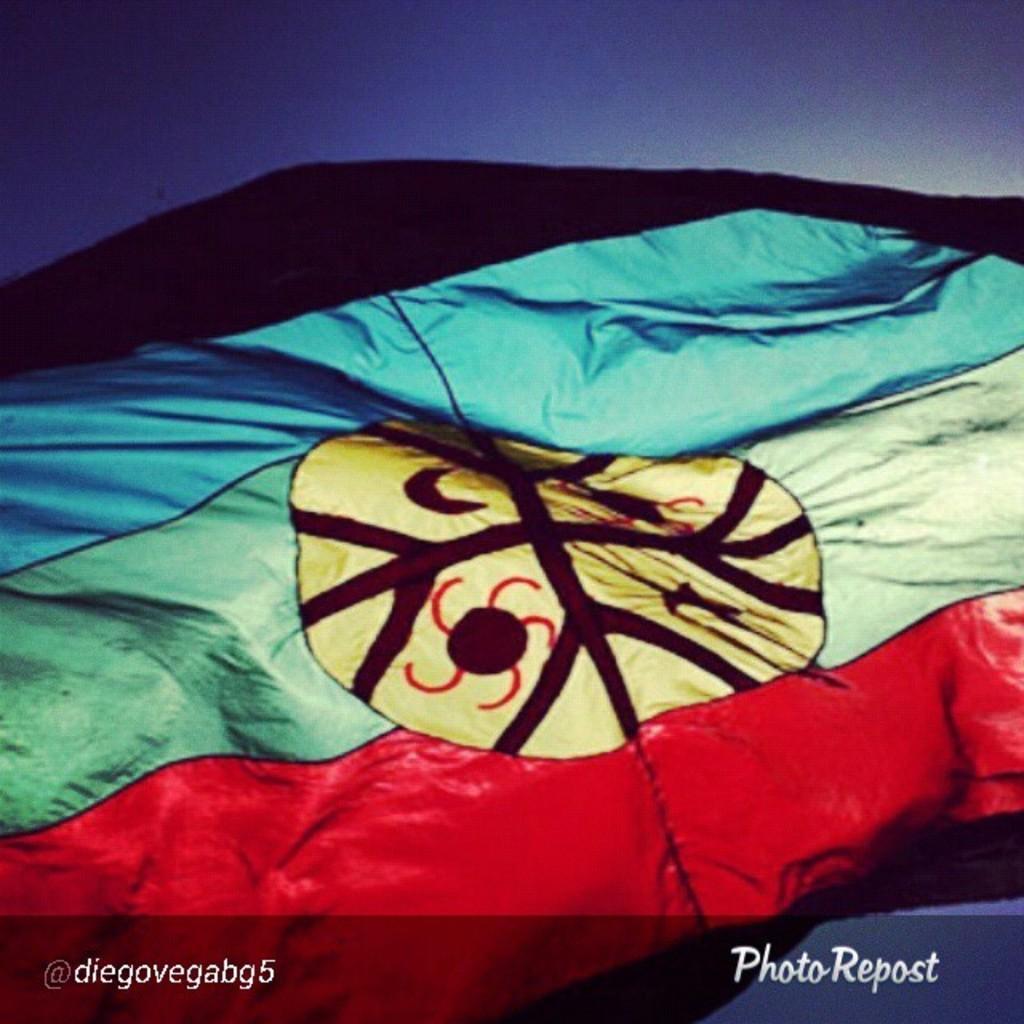Please provide a concise description of this image. In this picture, we see a cloth in black, red, green and yellow color. In the background, we see the sky, which is blue in color. This might be an edited image. 